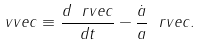<formula> <loc_0><loc_0><loc_500><loc_500>\ v v e c \equiv \frac { d \ r v e c } { d t } - \frac { { \dot { a } } } { a } \ r v e c .</formula> 